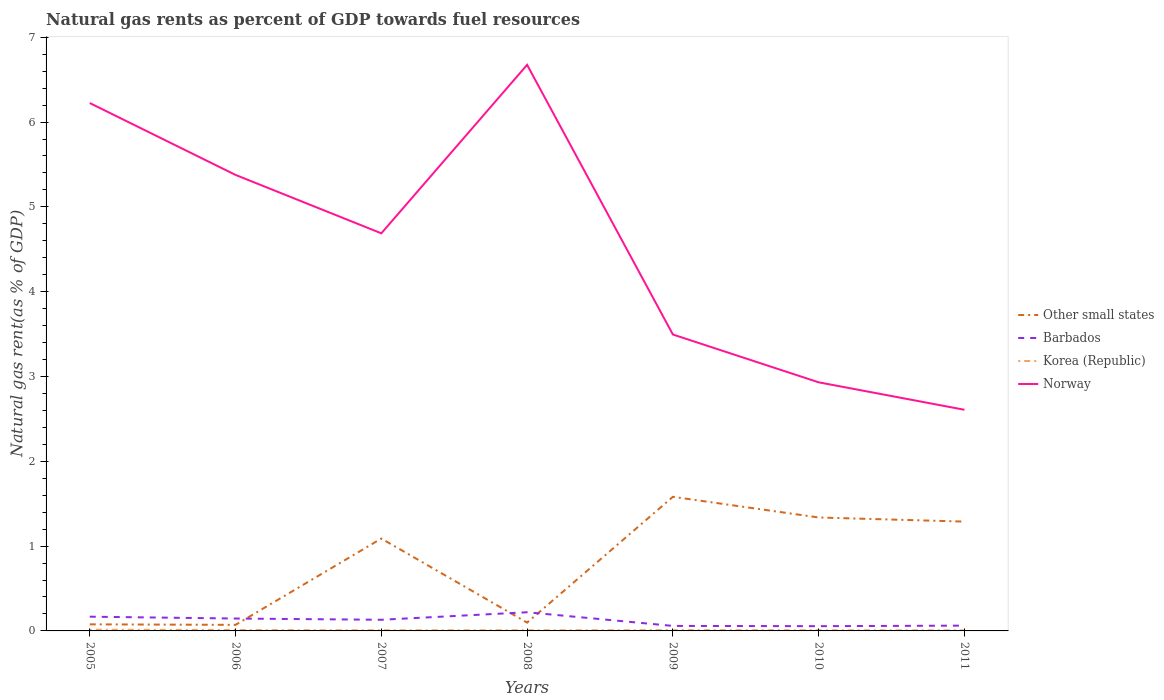Does the line corresponding to Norway intersect with the line corresponding to Korea (Republic)?
Keep it short and to the point. No. Is the number of lines equal to the number of legend labels?
Provide a short and direct response. Yes. Across all years, what is the maximum natural gas rent in Norway?
Ensure brevity in your answer.  2.61. What is the total natural gas rent in Norway in the graph?
Your response must be concise. 1.88. What is the difference between the highest and the second highest natural gas rent in Norway?
Give a very brief answer. 4.07. How many lines are there?
Your answer should be very brief. 4. How many years are there in the graph?
Give a very brief answer. 7. Does the graph contain any zero values?
Ensure brevity in your answer.  No. How many legend labels are there?
Offer a very short reply. 4. How are the legend labels stacked?
Offer a terse response. Vertical. What is the title of the graph?
Offer a very short reply. Natural gas rents as percent of GDP towards fuel resources. What is the label or title of the X-axis?
Provide a succinct answer. Years. What is the label or title of the Y-axis?
Your answer should be compact. Natural gas rent(as % of GDP). What is the Natural gas rent(as % of GDP) of Other small states in 2005?
Your response must be concise. 0.08. What is the Natural gas rent(as % of GDP) in Barbados in 2005?
Ensure brevity in your answer.  0.17. What is the Natural gas rent(as % of GDP) in Korea (Republic) in 2005?
Make the answer very short. 0.01. What is the Natural gas rent(as % of GDP) in Norway in 2005?
Ensure brevity in your answer.  6.22. What is the Natural gas rent(as % of GDP) of Other small states in 2006?
Provide a succinct answer. 0.07. What is the Natural gas rent(as % of GDP) in Barbados in 2006?
Your answer should be very brief. 0.15. What is the Natural gas rent(as % of GDP) in Korea (Republic) in 2006?
Ensure brevity in your answer.  0.01. What is the Natural gas rent(as % of GDP) in Norway in 2006?
Make the answer very short. 5.38. What is the Natural gas rent(as % of GDP) in Other small states in 2007?
Offer a very short reply. 1.09. What is the Natural gas rent(as % of GDP) of Barbados in 2007?
Provide a succinct answer. 0.13. What is the Natural gas rent(as % of GDP) in Korea (Republic) in 2007?
Keep it short and to the point. 0.01. What is the Natural gas rent(as % of GDP) in Norway in 2007?
Your answer should be compact. 4.69. What is the Natural gas rent(as % of GDP) in Other small states in 2008?
Give a very brief answer. 0.1. What is the Natural gas rent(as % of GDP) of Barbados in 2008?
Your response must be concise. 0.22. What is the Natural gas rent(as % of GDP) of Korea (Republic) in 2008?
Make the answer very short. 0.01. What is the Natural gas rent(as % of GDP) in Norway in 2008?
Offer a terse response. 6.67. What is the Natural gas rent(as % of GDP) in Other small states in 2009?
Offer a terse response. 1.58. What is the Natural gas rent(as % of GDP) of Barbados in 2009?
Provide a succinct answer. 0.06. What is the Natural gas rent(as % of GDP) in Korea (Republic) in 2009?
Ensure brevity in your answer.  0.01. What is the Natural gas rent(as % of GDP) in Norway in 2009?
Give a very brief answer. 3.49. What is the Natural gas rent(as % of GDP) of Other small states in 2010?
Your answer should be compact. 1.34. What is the Natural gas rent(as % of GDP) of Barbados in 2010?
Your answer should be very brief. 0.06. What is the Natural gas rent(as % of GDP) in Korea (Republic) in 2010?
Keep it short and to the point. 0.01. What is the Natural gas rent(as % of GDP) of Norway in 2010?
Provide a short and direct response. 2.93. What is the Natural gas rent(as % of GDP) in Other small states in 2011?
Provide a short and direct response. 1.29. What is the Natural gas rent(as % of GDP) of Barbados in 2011?
Offer a terse response. 0.06. What is the Natural gas rent(as % of GDP) of Korea (Republic) in 2011?
Make the answer very short. 0.01. What is the Natural gas rent(as % of GDP) of Norway in 2011?
Give a very brief answer. 2.61. Across all years, what is the maximum Natural gas rent(as % of GDP) of Other small states?
Ensure brevity in your answer.  1.58. Across all years, what is the maximum Natural gas rent(as % of GDP) in Barbados?
Your response must be concise. 0.22. Across all years, what is the maximum Natural gas rent(as % of GDP) in Korea (Republic)?
Offer a very short reply. 0.01. Across all years, what is the maximum Natural gas rent(as % of GDP) in Norway?
Provide a short and direct response. 6.67. Across all years, what is the minimum Natural gas rent(as % of GDP) in Other small states?
Your response must be concise. 0.07. Across all years, what is the minimum Natural gas rent(as % of GDP) in Barbados?
Make the answer very short. 0.06. Across all years, what is the minimum Natural gas rent(as % of GDP) in Korea (Republic)?
Your answer should be very brief. 0.01. Across all years, what is the minimum Natural gas rent(as % of GDP) of Norway?
Give a very brief answer. 2.61. What is the total Natural gas rent(as % of GDP) of Other small states in the graph?
Give a very brief answer. 5.54. What is the total Natural gas rent(as % of GDP) in Barbados in the graph?
Give a very brief answer. 0.84. What is the total Natural gas rent(as % of GDP) of Korea (Republic) in the graph?
Keep it short and to the point. 0.07. What is the total Natural gas rent(as % of GDP) of Norway in the graph?
Keep it short and to the point. 32. What is the difference between the Natural gas rent(as % of GDP) of Other small states in 2005 and that in 2006?
Your answer should be compact. 0.01. What is the difference between the Natural gas rent(as % of GDP) in Barbados in 2005 and that in 2006?
Give a very brief answer. 0.02. What is the difference between the Natural gas rent(as % of GDP) of Korea (Republic) in 2005 and that in 2006?
Offer a very short reply. 0. What is the difference between the Natural gas rent(as % of GDP) in Norway in 2005 and that in 2006?
Offer a terse response. 0.85. What is the difference between the Natural gas rent(as % of GDP) of Other small states in 2005 and that in 2007?
Give a very brief answer. -1.01. What is the difference between the Natural gas rent(as % of GDP) in Barbados in 2005 and that in 2007?
Your response must be concise. 0.04. What is the difference between the Natural gas rent(as % of GDP) in Korea (Republic) in 2005 and that in 2007?
Provide a short and direct response. 0.01. What is the difference between the Natural gas rent(as % of GDP) of Norway in 2005 and that in 2007?
Keep it short and to the point. 1.54. What is the difference between the Natural gas rent(as % of GDP) of Other small states in 2005 and that in 2008?
Provide a succinct answer. -0.02. What is the difference between the Natural gas rent(as % of GDP) in Barbados in 2005 and that in 2008?
Keep it short and to the point. -0.05. What is the difference between the Natural gas rent(as % of GDP) in Korea (Republic) in 2005 and that in 2008?
Offer a very short reply. 0.01. What is the difference between the Natural gas rent(as % of GDP) of Norway in 2005 and that in 2008?
Make the answer very short. -0.45. What is the difference between the Natural gas rent(as % of GDP) of Other small states in 2005 and that in 2009?
Your answer should be very brief. -1.5. What is the difference between the Natural gas rent(as % of GDP) of Barbados in 2005 and that in 2009?
Provide a succinct answer. 0.11. What is the difference between the Natural gas rent(as % of GDP) of Korea (Republic) in 2005 and that in 2009?
Ensure brevity in your answer.  0. What is the difference between the Natural gas rent(as % of GDP) in Norway in 2005 and that in 2009?
Give a very brief answer. 2.73. What is the difference between the Natural gas rent(as % of GDP) in Other small states in 2005 and that in 2010?
Offer a very short reply. -1.26. What is the difference between the Natural gas rent(as % of GDP) in Barbados in 2005 and that in 2010?
Your answer should be very brief. 0.11. What is the difference between the Natural gas rent(as % of GDP) of Korea (Republic) in 2005 and that in 2010?
Your answer should be compact. 0.01. What is the difference between the Natural gas rent(as % of GDP) of Norway in 2005 and that in 2010?
Make the answer very short. 3.29. What is the difference between the Natural gas rent(as % of GDP) of Other small states in 2005 and that in 2011?
Offer a very short reply. -1.21. What is the difference between the Natural gas rent(as % of GDP) in Barbados in 2005 and that in 2011?
Offer a very short reply. 0.11. What is the difference between the Natural gas rent(as % of GDP) in Korea (Republic) in 2005 and that in 2011?
Keep it short and to the point. 0.01. What is the difference between the Natural gas rent(as % of GDP) in Norway in 2005 and that in 2011?
Provide a succinct answer. 3.62. What is the difference between the Natural gas rent(as % of GDP) of Other small states in 2006 and that in 2007?
Ensure brevity in your answer.  -1.02. What is the difference between the Natural gas rent(as % of GDP) of Barbados in 2006 and that in 2007?
Your answer should be very brief. 0.01. What is the difference between the Natural gas rent(as % of GDP) of Korea (Republic) in 2006 and that in 2007?
Your answer should be compact. 0. What is the difference between the Natural gas rent(as % of GDP) in Norway in 2006 and that in 2007?
Offer a terse response. 0.69. What is the difference between the Natural gas rent(as % of GDP) in Other small states in 2006 and that in 2008?
Make the answer very short. -0.03. What is the difference between the Natural gas rent(as % of GDP) in Barbados in 2006 and that in 2008?
Give a very brief answer. -0.07. What is the difference between the Natural gas rent(as % of GDP) in Korea (Republic) in 2006 and that in 2008?
Make the answer very short. 0. What is the difference between the Natural gas rent(as % of GDP) in Norway in 2006 and that in 2008?
Keep it short and to the point. -1.3. What is the difference between the Natural gas rent(as % of GDP) of Other small states in 2006 and that in 2009?
Your response must be concise. -1.51. What is the difference between the Natural gas rent(as % of GDP) of Barbados in 2006 and that in 2009?
Ensure brevity in your answer.  0.09. What is the difference between the Natural gas rent(as % of GDP) in Korea (Republic) in 2006 and that in 2009?
Your response must be concise. 0. What is the difference between the Natural gas rent(as % of GDP) in Norway in 2006 and that in 2009?
Ensure brevity in your answer.  1.88. What is the difference between the Natural gas rent(as % of GDP) of Other small states in 2006 and that in 2010?
Your answer should be very brief. -1.27. What is the difference between the Natural gas rent(as % of GDP) in Barbados in 2006 and that in 2010?
Provide a short and direct response. 0.09. What is the difference between the Natural gas rent(as % of GDP) of Korea (Republic) in 2006 and that in 2010?
Your answer should be compact. 0. What is the difference between the Natural gas rent(as % of GDP) in Norway in 2006 and that in 2010?
Make the answer very short. 2.45. What is the difference between the Natural gas rent(as % of GDP) of Other small states in 2006 and that in 2011?
Your response must be concise. -1.22. What is the difference between the Natural gas rent(as % of GDP) in Barbados in 2006 and that in 2011?
Give a very brief answer. 0.08. What is the difference between the Natural gas rent(as % of GDP) in Korea (Republic) in 2006 and that in 2011?
Give a very brief answer. 0. What is the difference between the Natural gas rent(as % of GDP) of Norway in 2006 and that in 2011?
Make the answer very short. 2.77. What is the difference between the Natural gas rent(as % of GDP) of Barbados in 2007 and that in 2008?
Your answer should be compact. -0.09. What is the difference between the Natural gas rent(as % of GDP) in Korea (Republic) in 2007 and that in 2008?
Your answer should be very brief. -0. What is the difference between the Natural gas rent(as % of GDP) in Norway in 2007 and that in 2008?
Ensure brevity in your answer.  -1.99. What is the difference between the Natural gas rent(as % of GDP) in Other small states in 2007 and that in 2009?
Your response must be concise. -0.49. What is the difference between the Natural gas rent(as % of GDP) of Barbados in 2007 and that in 2009?
Provide a short and direct response. 0.07. What is the difference between the Natural gas rent(as % of GDP) of Korea (Republic) in 2007 and that in 2009?
Your response must be concise. -0. What is the difference between the Natural gas rent(as % of GDP) of Norway in 2007 and that in 2009?
Offer a terse response. 1.19. What is the difference between the Natural gas rent(as % of GDP) in Other small states in 2007 and that in 2010?
Give a very brief answer. -0.25. What is the difference between the Natural gas rent(as % of GDP) in Barbados in 2007 and that in 2010?
Your response must be concise. 0.08. What is the difference between the Natural gas rent(as % of GDP) of Korea (Republic) in 2007 and that in 2010?
Make the answer very short. -0. What is the difference between the Natural gas rent(as % of GDP) in Norway in 2007 and that in 2010?
Offer a very short reply. 1.76. What is the difference between the Natural gas rent(as % of GDP) of Other small states in 2007 and that in 2011?
Offer a terse response. -0.2. What is the difference between the Natural gas rent(as % of GDP) of Barbados in 2007 and that in 2011?
Provide a short and direct response. 0.07. What is the difference between the Natural gas rent(as % of GDP) in Korea (Republic) in 2007 and that in 2011?
Offer a terse response. 0. What is the difference between the Natural gas rent(as % of GDP) of Norway in 2007 and that in 2011?
Ensure brevity in your answer.  2.08. What is the difference between the Natural gas rent(as % of GDP) of Other small states in 2008 and that in 2009?
Provide a succinct answer. -1.48. What is the difference between the Natural gas rent(as % of GDP) in Barbados in 2008 and that in 2009?
Provide a succinct answer. 0.16. What is the difference between the Natural gas rent(as % of GDP) of Korea (Republic) in 2008 and that in 2009?
Ensure brevity in your answer.  -0. What is the difference between the Natural gas rent(as % of GDP) of Norway in 2008 and that in 2009?
Your response must be concise. 3.18. What is the difference between the Natural gas rent(as % of GDP) in Other small states in 2008 and that in 2010?
Make the answer very short. -1.24. What is the difference between the Natural gas rent(as % of GDP) in Barbados in 2008 and that in 2010?
Ensure brevity in your answer.  0.16. What is the difference between the Natural gas rent(as % of GDP) in Norway in 2008 and that in 2010?
Provide a succinct answer. 3.74. What is the difference between the Natural gas rent(as % of GDP) of Other small states in 2008 and that in 2011?
Your response must be concise. -1.19. What is the difference between the Natural gas rent(as % of GDP) of Barbados in 2008 and that in 2011?
Offer a terse response. 0.16. What is the difference between the Natural gas rent(as % of GDP) of Korea (Republic) in 2008 and that in 2011?
Make the answer very short. 0. What is the difference between the Natural gas rent(as % of GDP) of Norway in 2008 and that in 2011?
Give a very brief answer. 4.07. What is the difference between the Natural gas rent(as % of GDP) of Other small states in 2009 and that in 2010?
Provide a short and direct response. 0.24. What is the difference between the Natural gas rent(as % of GDP) of Barbados in 2009 and that in 2010?
Your response must be concise. 0. What is the difference between the Natural gas rent(as % of GDP) of Korea (Republic) in 2009 and that in 2010?
Your answer should be compact. 0. What is the difference between the Natural gas rent(as % of GDP) of Norway in 2009 and that in 2010?
Provide a succinct answer. 0.56. What is the difference between the Natural gas rent(as % of GDP) in Other small states in 2009 and that in 2011?
Provide a short and direct response. 0.29. What is the difference between the Natural gas rent(as % of GDP) of Barbados in 2009 and that in 2011?
Your response must be concise. -0. What is the difference between the Natural gas rent(as % of GDP) in Korea (Republic) in 2009 and that in 2011?
Offer a terse response. 0. What is the difference between the Natural gas rent(as % of GDP) of Norway in 2009 and that in 2011?
Ensure brevity in your answer.  0.89. What is the difference between the Natural gas rent(as % of GDP) in Other small states in 2010 and that in 2011?
Offer a very short reply. 0.05. What is the difference between the Natural gas rent(as % of GDP) of Barbados in 2010 and that in 2011?
Your answer should be compact. -0.01. What is the difference between the Natural gas rent(as % of GDP) of Korea (Republic) in 2010 and that in 2011?
Keep it short and to the point. 0. What is the difference between the Natural gas rent(as % of GDP) in Norway in 2010 and that in 2011?
Give a very brief answer. 0.32. What is the difference between the Natural gas rent(as % of GDP) of Other small states in 2005 and the Natural gas rent(as % of GDP) of Barbados in 2006?
Offer a very short reply. -0.07. What is the difference between the Natural gas rent(as % of GDP) in Other small states in 2005 and the Natural gas rent(as % of GDP) in Korea (Republic) in 2006?
Provide a short and direct response. 0.07. What is the difference between the Natural gas rent(as % of GDP) in Other small states in 2005 and the Natural gas rent(as % of GDP) in Norway in 2006?
Make the answer very short. -5.3. What is the difference between the Natural gas rent(as % of GDP) in Barbados in 2005 and the Natural gas rent(as % of GDP) in Korea (Republic) in 2006?
Give a very brief answer. 0.16. What is the difference between the Natural gas rent(as % of GDP) of Barbados in 2005 and the Natural gas rent(as % of GDP) of Norway in 2006?
Give a very brief answer. -5.21. What is the difference between the Natural gas rent(as % of GDP) in Korea (Republic) in 2005 and the Natural gas rent(as % of GDP) in Norway in 2006?
Keep it short and to the point. -5.36. What is the difference between the Natural gas rent(as % of GDP) in Other small states in 2005 and the Natural gas rent(as % of GDP) in Barbados in 2007?
Offer a very short reply. -0.05. What is the difference between the Natural gas rent(as % of GDP) in Other small states in 2005 and the Natural gas rent(as % of GDP) in Korea (Republic) in 2007?
Ensure brevity in your answer.  0.07. What is the difference between the Natural gas rent(as % of GDP) of Other small states in 2005 and the Natural gas rent(as % of GDP) of Norway in 2007?
Make the answer very short. -4.61. What is the difference between the Natural gas rent(as % of GDP) in Barbados in 2005 and the Natural gas rent(as % of GDP) in Korea (Republic) in 2007?
Keep it short and to the point. 0.16. What is the difference between the Natural gas rent(as % of GDP) of Barbados in 2005 and the Natural gas rent(as % of GDP) of Norway in 2007?
Keep it short and to the point. -4.52. What is the difference between the Natural gas rent(as % of GDP) of Korea (Republic) in 2005 and the Natural gas rent(as % of GDP) of Norway in 2007?
Provide a short and direct response. -4.67. What is the difference between the Natural gas rent(as % of GDP) in Other small states in 2005 and the Natural gas rent(as % of GDP) in Barbados in 2008?
Keep it short and to the point. -0.14. What is the difference between the Natural gas rent(as % of GDP) in Other small states in 2005 and the Natural gas rent(as % of GDP) in Korea (Republic) in 2008?
Offer a very short reply. 0.07. What is the difference between the Natural gas rent(as % of GDP) of Other small states in 2005 and the Natural gas rent(as % of GDP) of Norway in 2008?
Make the answer very short. -6.6. What is the difference between the Natural gas rent(as % of GDP) in Barbados in 2005 and the Natural gas rent(as % of GDP) in Korea (Republic) in 2008?
Give a very brief answer. 0.16. What is the difference between the Natural gas rent(as % of GDP) of Barbados in 2005 and the Natural gas rent(as % of GDP) of Norway in 2008?
Offer a very short reply. -6.51. What is the difference between the Natural gas rent(as % of GDP) of Korea (Republic) in 2005 and the Natural gas rent(as % of GDP) of Norway in 2008?
Provide a succinct answer. -6.66. What is the difference between the Natural gas rent(as % of GDP) in Other small states in 2005 and the Natural gas rent(as % of GDP) in Barbados in 2009?
Offer a terse response. 0.02. What is the difference between the Natural gas rent(as % of GDP) of Other small states in 2005 and the Natural gas rent(as % of GDP) of Korea (Republic) in 2009?
Provide a succinct answer. 0.07. What is the difference between the Natural gas rent(as % of GDP) of Other small states in 2005 and the Natural gas rent(as % of GDP) of Norway in 2009?
Your answer should be very brief. -3.42. What is the difference between the Natural gas rent(as % of GDP) in Barbados in 2005 and the Natural gas rent(as % of GDP) in Korea (Republic) in 2009?
Keep it short and to the point. 0.16. What is the difference between the Natural gas rent(as % of GDP) in Barbados in 2005 and the Natural gas rent(as % of GDP) in Norway in 2009?
Make the answer very short. -3.33. What is the difference between the Natural gas rent(as % of GDP) in Korea (Republic) in 2005 and the Natural gas rent(as % of GDP) in Norway in 2009?
Give a very brief answer. -3.48. What is the difference between the Natural gas rent(as % of GDP) in Other small states in 2005 and the Natural gas rent(as % of GDP) in Barbados in 2010?
Provide a short and direct response. 0.02. What is the difference between the Natural gas rent(as % of GDP) of Other small states in 2005 and the Natural gas rent(as % of GDP) of Korea (Republic) in 2010?
Your answer should be very brief. 0.07. What is the difference between the Natural gas rent(as % of GDP) of Other small states in 2005 and the Natural gas rent(as % of GDP) of Norway in 2010?
Your answer should be very brief. -2.85. What is the difference between the Natural gas rent(as % of GDP) of Barbados in 2005 and the Natural gas rent(as % of GDP) of Korea (Republic) in 2010?
Offer a very short reply. 0.16. What is the difference between the Natural gas rent(as % of GDP) of Barbados in 2005 and the Natural gas rent(as % of GDP) of Norway in 2010?
Provide a short and direct response. -2.76. What is the difference between the Natural gas rent(as % of GDP) of Korea (Republic) in 2005 and the Natural gas rent(as % of GDP) of Norway in 2010?
Offer a very short reply. -2.92. What is the difference between the Natural gas rent(as % of GDP) of Other small states in 2005 and the Natural gas rent(as % of GDP) of Barbados in 2011?
Give a very brief answer. 0.02. What is the difference between the Natural gas rent(as % of GDP) of Other small states in 2005 and the Natural gas rent(as % of GDP) of Korea (Republic) in 2011?
Ensure brevity in your answer.  0.07. What is the difference between the Natural gas rent(as % of GDP) in Other small states in 2005 and the Natural gas rent(as % of GDP) in Norway in 2011?
Your response must be concise. -2.53. What is the difference between the Natural gas rent(as % of GDP) of Barbados in 2005 and the Natural gas rent(as % of GDP) of Korea (Republic) in 2011?
Provide a short and direct response. 0.16. What is the difference between the Natural gas rent(as % of GDP) of Barbados in 2005 and the Natural gas rent(as % of GDP) of Norway in 2011?
Offer a very short reply. -2.44. What is the difference between the Natural gas rent(as % of GDP) in Korea (Republic) in 2005 and the Natural gas rent(as % of GDP) in Norway in 2011?
Give a very brief answer. -2.59. What is the difference between the Natural gas rent(as % of GDP) in Other small states in 2006 and the Natural gas rent(as % of GDP) in Barbados in 2007?
Provide a short and direct response. -0.06. What is the difference between the Natural gas rent(as % of GDP) in Other small states in 2006 and the Natural gas rent(as % of GDP) in Korea (Republic) in 2007?
Offer a very short reply. 0.06. What is the difference between the Natural gas rent(as % of GDP) of Other small states in 2006 and the Natural gas rent(as % of GDP) of Norway in 2007?
Your answer should be very brief. -4.62. What is the difference between the Natural gas rent(as % of GDP) in Barbados in 2006 and the Natural gas rent(as % of GDP) in Korea (Republic) in 2007?
Give a very brief answer. 0.14. What is the difference between the Natural gas rent(as % of GDP) in Barbados in 2006 and the Natural gas rent(as % of GDP) in Norway in 2007?
Your response must be concise. -4.54. What is the difference between the Natural gas rent(as % of GDP) in Korea (Republic) in 2006 and the Natural gas rent(as % of GDP) in Norway in 2007?
Provide a succinct answer. -4.68. What is the difference between the Natural gas rent(as % of GDP) of Other small states in 2006 and the Natural gas rent(as % of GDP) of Barbados in 2008?
Make the answer very short. -0.15. What is the difference between the Natural gas rent(as % of GDP) in Other small states in 2006 and the Natural gas rent(as % of GDP) in Korea (Republic) in 2008?
Keep it short and to the point. 0.06. What is the difference between the Natural gas rent(as % of GDP) in Other small states in 2006 and the Natural gas rent(as % of GDP) in Norway in 2008?
Keep it short and to the point. -6.6. What is the difference between the Natural gas rent(as % of GDP) in Barbados in 2006 and the Natural gas rent(as % of GDP) in Korea (Republic) in 2008?
Provide a short and direct response. 0.14. What is the difference between the Natural gas rent(as % of GDP) of Barbados in 2006 and the Natural gas rent(as % of GDP) of Norway in 2008?
Your answer should be very brief. -6.53. What is the difference between the Natural gas rent(as % of GDP) in Korea (Republic) in 2006 and the Natural gas rent(as % of GDP) in Norway in 2008?
Your answer should be very brief. -6.66. What is the difference between the Natural gas rent(as % of GDP) of Other small states in 2006 and the Natural gas rent(as % of GDP) of Barbados in 2009?
Give a very brief answer. 0.01. What is the difference between the Natural gas rent(as % of GDP) of Other small states in 2006 and the Natural gas rent(as % of GDP) of Korea (Republic) in 2009?
Keep it short and to the point. 0.06. What is the difference between the Natural gas rent(as % of GDP) in Other small states in 2006 and the Natural gas rent(as % of GDP) in Norway in 2009?
Your answer should be very brief. -3.42. What is the difference between the Natural gas rent(as % of GDP) of Barbados in 2006 and the Natural gas rent(as % of GDP) of Korea (Republic) in 2009?
Give a very brief answer. 0.14. What is the difference between the Natural gas rent(as % of GDP) of Barbados in 2006 and the Natural gas rent(as % of GDP) of Norway in 2009?
Keep it short and to the point. -3.35. What is the difference between the Natural gas rent(as % of GDP) of Korea (Republic) in 2006 and the Natural gas rent(as % of GDP) of Norway in 2009?
Provide a succinct answer. -3.48. What is the difference between the Natural gas rent(as % of GDP) in Other small states in 2006 and the Natural gas rent(as % of GDP) in Barbados in 2010?
Give a very brief answer. 0.02. What is the difference between the Natural gas rent(as % of GDP) of Other small states in 2006 and the Natural gas rent(as % of GDP) of Korea (Republic) in 2010?
Give a very brief answer. 0.06. What is the difference between the Natural gas rent(as % of GDP) of Other small states in 2006 and the Natural gas rent(as % of GDP) of Norway in 2010?
Your answer should be very brief. -2.86. What is the difference between the Natural gas rent(as % of GDP) in Barbados in 2006 and the Natural gas rent(as % of GDP) in Korea (Republic) in 2010?
Provide a succinct answer. 0.14. What is the difference between the Natural gas rent(as % of GDP) of Barbados in 2006 and the Natural gas rent(as % of GDP) of Norway in 2010?
Ensure brevity in your answer.  -2.79. What is the difference between the Natural gas rent(as % of GDP) of Korea (Republic) in 2006 and the Natural gas rent(as % of GDP) of Norway in 2010?
Keep it short and to the point. -2.92. What is the difference between the Natural gas rent(as % of GDP) in Other small states in 2006 and the Natural gas rent(as % of GDP) in Barbados in 2011?
Make the answer very short. 0.01. What is the difference between the Natural gas rent(as % of GDP) of Other small states in 2006 and the Natural gas rent(as % of GDP) of Korea (Republic) in 2011?
Offer a very short reply. 0.06. What is the difference between the Natural gas rent(as % of GDP) of Other small states in 2006 and the Natural gas rent(as % of GDP) of Norway in 2011?
Offer a very short reply. -2.54. What is the difference between the Natural gas rent(as % of GDP) of Barbados in 2006 and the Natural gas rent(as % of GDP) of Korea (Republic) in 2011?
Your answer should be compact. 0.14. What is the difference between the Natural gas rent(as % of GDP) in Barbados in 2006 and the Natural gas rent(as % of GDP) in Norway in 2011?
Offer a terse response. -2.46. What is the difference between the Natural gas rent(as % of GDP) of Korea (Republic) in 2006 and the Natural gas rent(as % of GDP) of Norway in 2011?
Provide a succinct answer. -2.6. What is the difference between the Natural gas rent(as % of GDP) in Other small states in 2007 and the Natural gas rent(as % of GDP) in Barbados in 2008?
Provide a short and direct response. 0.87. What is the difference between the Natural gas rent(as % of GDP) in Other small states in 2007 and the Natural gas rent(as % of GDP) in Korea (Republic) in 2008?
Give a very brief answer. 1.08. What is the difference between the Natural gas rent(as % of GDP) in Other small states in 2007 and the Natural gas rent(as % of GDP) in Norway in 2008?
Give a very brief answer. -5.59. What is the difference between the Natural gas rent(as % of GDP) in Barbados in 2007 and the Natural gas rent(as % of GDP) in Korea (Republic) in 2008?
Make the answer very short. 0.12. What is the difference between the Natural gas rent(as % of GDP) of Barbados in 2007 and the Natural gas rent(as % of GDP) of Norway in 2008?
Provide a short and direct response. -6.54. What is the difference between the Natural gas rent(as % of GDP) of Korea (Republic) in 2007 and the Natural gas rent(as % of GDP) of Norway in 2008?
Make the answer very short. -6.67. What is the difference between the Natural gas rent(as % of GDP) of Other small states in 2007 and the Natural gas rent(as % of GDP) of Barbados in 2009?
Your answer should be compact. 1.03. What is the difference between the Natural gas rent(as % of GDP) of Other small states in 2007 and the Natural gas rent(as % of GDP) of Korea (Republic) in 2009?
Provide a succinct answer. 1.08. What is the difference between the Natural gas rent(as % of GDP) in Other small states in 2007 and the Natural gas rent(as % of GDP) in Norway in 2009?
Ensure brevity in your answer.  -2.41. What is the difference between the Natural gas rent(as % of GDP) of Barbados in 2007 and the Natural gas rent(as % of GDP) of Korea (Republic) in 2009?
Provide a short and direct response. 0.12. What is the difference between the Natural gas rent(as % of GDP) in Barbados in 2007 and the Natural gas rent(as % of GDP) in Norway in 2009?
Ensure brevity in your answer.  -3.36. What is the difference between the Natural gas rent(as % of GDP) in Korea (Republic) in 2007 and the Natural gas rent(as % of GDP) in Norway in 2009?
Ensure brevity in your answer.  -3.49. What is the difference between the Natural gas rent(as % of GDP) of Other small states in 2007 and the Natural gas rent(as % of GDP) of Barbados in 2010?
Offer a very short reply. 1.03. What is the difference between the Natural gas rent(as % of GDP) of Other small states in 2007 and the Natural gas rent(as % of GDP) of Korea (Republic) in 2010?
Offer a very short reply. 1.08. What is the difference between the Natural gas rent(as % of GDP) in Other small states in 2007 and the Natural gas rent(as % of GDP) in Norway in 2010?
Give a very brief answer. -1.84. What is the difference between the Natural gas rent(as % of GDP) of Barbados in 2007 and the Natural gas rent(as % of GDP) of Korea (Republic) in 2010?
Provide a short and direct response. 0.12. What is the difference between the Natural gas rent(as % of GDP) of Barbados in 2007 and the Natural gas rent(as % of GDP) of Norway in 2010?
Offer a very short reply. -2.8. What is the difference between the Natural gas rent(as % of GDP) in Korea (Republic) in 2007 and the Natural gas rent(as % of GDP) in Norway in 2010?
Make the answer very short. -2.92. What is the difference between the Natural gas rent(as % of GDP) of Other small states in 2007 and the Natural gas rent(as % of GDP) of Barbados in 2011?
Your answer should be very brief. 1.03. What is the difference between the Natural gas rent(as % of GDP) in Other small states in 2007 and the Natural gas rent(as % of GDP) in Korea (Republic) in 2011?
Your answer should be very brief. 1.08. What is the difference between the Natural gas rent(as % of GDP) of Other small states in 2007 and the Natural gas rent(as % of GDP) of Norway in 2011?
Provide a succinct answer. -1.52. What is the difference between the Natural gas rent(as % of GDP) in Barbados in 2007 and the Natural gas rent(as % of GDP) in Korea (Republic) in 2011?
Keep it short and to the point. 0.12. What is the difference between the Natural gas rent(as % of GDP) in Barbados in 2007 and the Natural gas rent(as % of GDP) in Norway in 2011?
Your response must be concise. -2.48. What is the difference between the Natural gas rent(as % of GDP) of Korea (Republic) in 2007 and the Natural gas rent(as % of GDP) of Norway in 2011?
Make the answer very short. -2.6. What is the difference between the Natural gas rent(as % of GDP) in Other small states in 2008 and the Natural gas rent(as % of GDP) in Barbados in 2009?
Provide a short and direct response. 0.04. What is the difference between the Natural gas rent(as % of GDP) in Other small states in 2008 and the Natural gas rent(as % of GDP) in Korea (Republic) in 2009?
Make the answer very short. 0.09. What is the difference between the Natural gas rent(as % of GDP) in Other small states in 2008 and the Natural gas rent(as % of GDP) in Norway in 2009?
Your answer should be very brief. -3.4. What is the difference between the Natural gas rent(as % of GDP) in Barbados in 2008 and the Natural gas rent(as % of GDP) in Korea (Republic) in 2009?
Your answer should be very brief. 0.21. What is the difference between the Natural gas rent(as % of GDP) in Barbados in 2008 and the Natural gas rent(as % of GDP) in Norway in 2009?
Your response must be concise. -3.27. What is the difference between the Natural gas rent(as % of GDP) of Korea (Republic) in 2008 and the Natural gas rent(as % of GDP) of Norway in 2009?
Your answer should be compact. -3.49. What is the difference between the Natural gas rent(as % of GDP) of Other small states in 2008 and the Natural gas rent(as % of GDP) of Barbados in 2010?
Provide a succinct answer. 0.04. What is the difference between the Natural gas rent(as % of GDP) of Other small states in 2008 and the Natural gas rent(as % of GDP) of Korea (Republic) in 2010?
Your answer should be very brief. 0.09. What is the difference between the Natural gas rent(as % of GDP) of Other small states in 2008 and the Natural gas rent(as % of GDP) of Norway in 2010?
Provide a short and direct response. -2.83. What is the difference between the Natural gas rent(as % of GDP) of Barbados in 2008 and the Natural gas rent(as % of GDP) of Korea (Republic) in 2010?
Your answer should be very brief. 0.21. What is the difference between the Natural gas rent(as % of GDP) of Barbados in 2008 and the Natural gas rent(as % of GDP) of Norway in 2010?
Make the answer very short. -2.71. What is the difference between the Natural gas rent(as % of GDP) of Korea (Republic) in 2008 and the Natural gas rent(as % of GDP) of Norway in 2010?
Give a very brief answer. -2.92. What is the difference between the Natural gas rent(as % of GDP) of Other small states in 2008 and the Natural gas rent(as % of GDP) of Barbados in 2011?
Keep it short and to the point. 0.04. What is the difference between the Natural gas rent(as % of GDP) of Other small states in 2008 and the Natural gas rent(as % of GDP) of Korea (Republic) in 2011?
Your answer should be compact. 0.09. What is the difference between the Natural gas rent(as % of GDP) in Other small states in 2008 and the Natural gas rent(as % of GDP) in Norway in 2011?
Keep it short and to the point. -2.51. What is the difference between the Natural gas rent(as % of GDP) of Barbados in 2008 and the Natural gas rent(as % of GDP) of Korea (Republic) in 2011?
Your answer should be very brief. 0.21. What is the difference between the Natural gas rent(as % of GDP) in Barbados in 2008 and the Natural gas rent(as % of GDP) in Norway in 2011?
Provide a short and direct response. -2.39. What is the difference between the Natural gas rent(as % of GDP) in Korea (Republic) in 2008 and the Natural gas rent(as % of GDP) in Norway in 2011?
Your answer should be compact. -2.6. What is the difference between the Natural gas rent(as % of GDP) in Other small states in 2009 and the Natural gas rent(as % of GDP) in Barbados in 2010?
Provide a short and direct response. 1.53. What is the difference between the Natural gas rent(as % of GDP) in Other small states in 2009 and the Natural gas rent(as % of GDP) in Korea (Republic) in 2010?
Offer a terse response. 1.57. What is the difference between the Natural gas rent(as % of GDP) in Other small states in 2009 and the Natural gas rent(as % of GDP) in Norway in 2010?
Offer a terse response. -1.35. What is the difference between the Natural gas rent(as % of GDP) of Barbados in 2009 and the Natural gas rent(as % of GDP) of Korea (Republic) in 2010?
Provide a short and direct response. 0.05. What is the difference between the Natural gas rent(as % of GDP) in Barbados in 2009 and the Natural gas rent(as % of GDP) in Norway in 2010?
Your answer should be very brief. -2.87. What is the difference between the Natural gas rent(as % of GDP) of Korea (Republic) in 2009 and the Natural gas rent(as % of GDP) of Norway in 2010?
Give a very brief answer. -2.92. What is the difference between the Natural gas rent(as % of GDP) in Other small states in 2009 and the Natural gas rent(as % of GDP) in Barbados in 2011?
Ensure brevity in your answer.  1.52. What is the difference between the Natural gas rent(as % of GDP) in Other small states in 2009 and the Natural gas rent(as % of GDP) in Korea (Republic) in 2011?
Your answer should be very brief. 1.57. What is the difference between the Natural gas rent(as % of GDP) in Other small states in 2009 and the Natural gas rent(as % of GDP) in Norway in 2011?
Provide a short and direct response. -1.03. What is the difference between the Natural gas rent(as % of GDP) in Barbados in 2009 and the Natural gas rent(as % of GDP) in Korea (Republic) in 2011?
Your answer should be very brief. 0.05. What is the difference between the Natural gas rent(as % of GDP) in Barbados in 2009 and the Natural gas rent(as % of GDP) in Norway in 2011?
Your answer should be very brief. -2.55. What is the difference between the Natural gas rent(as % of GDP) of Korea (Republic) in 2009 and the Natural gas rent(as % of GDP) of Norway in 2011?
Your response must be concise. -2.6. What is the difference between the Natural gas rent(as % of GDP) of Other small states in 2010 and the Natural gas rent(as % of GDP) of Barbados in 2011?
Your response must be concise. 1.28. What is the difference between the Natural gas rent(as % of GDP) in Other small states in 2010 and the Natural gas rent(as % of GDP) in Korea (Republic) in 2011?
Offer a terse response. 1.33. What is the difference between the Natural gas rent(as % of GDP) in Other small states in 2010 and the Natural gas rent(as % of GDP) in Norway in 2011?
Provide a short and direct response. -1.27. What is the difference between the Natural gas rent(as % of GDP) in Barbados in 2010 and the Natural gas rent(as % of GDP) in Korea (Republic) in 2011?
Ensure brevity in your answer.  0.05. What is the difference between the Natural gas rent(as % of GDP) of Barbados in 2010 and the Natural gas rent(as % of GDP) of Norway in 2011?
Give a very brief answer. -2.55. What is the difference between the Natural gas rent(as % of GDP) of Korea (Republic) in 2010 and the Natural gas rent(as % of GDP) of Norway in 2011?
Your response must be concise. -2.6. What is the average Natural gas rent(as % of GDP) of Other small states per year?
Give a very brief answer. 0.79. What is the average Natural gas rent(as % of GDP) of Barbados per year?
Your answer should be very brief. 0.12. What is the average Natural gas rent(as % of GDP) in Korea (Republic) per year?
Provide a succinct answer. 0.01. What is the average Natural gas rent(as % of GDP) in Norway per year?
Your answer should be very brief. 4.57. In the year 2005, what is the difference between the Natural gas rent(as % of GDP) of Other small states and Natural gas rent(as % of GDP) of Barbados?
Provide a succinct answer. -0.09. In the year 2005, what is the difference between the Natural gas rent(as % of GDP) in Other small states and Natural gas rent(as % of GDP) in Korea (Republic)?
Provide a short and direct response. 0.06. In the year 2005, what is the difference between the Natural gas rent(as % of GDP) of Other small states and Natural gas rent(as % of GDP) of Norway?
Your response must be concise. -6.15. In the year 2005, what is the difference between the Natural gas rent(as % of GDP) of Barbados and Natural gas rent(as % of GDP) of Korea (Republic)?
Offer a very short reply. 0.15. In the year 2005, what is the difference between the Natural gas rent(as % of GDP) of Barbados and Natural gas rent(as % of GDP) of Norway?
Provide a short and direct response. -6.06. In the year 2005, what is the difference between the Natural gas rent(as % of GDP) of Korea (Republic) and Natural gas rent(as % of GDP) of Norway?
Give a very brief answer. -6.21. In the year 2006, what is the difference between the Natural gas rent(as % of GDP) in Other small states and Natural gas rent(as % of GDP) in Barbados?
Offer a very short reply. -0.07. In the year 2006, what is the difference between the Natural gas rent(as % of GDP) of Other small states and Natural gas rent(as % of GDP) of Korea (Republic)?
Keep it short and to the point. 0.06. In the year 2006, what is the difference between the Natural gas rent(as % of GDP) of Other small states and Natural gas rent(as % of GDP) of Norway?
Your answer should be compact. -5.31. In the year 2006, what is the difference between the Natural gas rent(as % of GDP) in Barbados and Natural gas rent(as % of GDP) in Korea (Republic)?
Your response must be concise. 0.14. In the year 2006, what is the difference between the Natural gas rent(as % of GDP) of Barbados and Natural gas rent(as % of GDP) of Norway?
Offer a very short reply. -5.23. In the year 2006, what is the difference between the Natural gas rent(as % of GDP) in Korea (Republic) and Natural gas rent(as % of GDP) in Norway?
Offer a very short reply. -5.37. In the year 2007, what is the difference between the Natural gas rent(as % of GDP) in Other small states and Natural gas rent(as % of GDP) in Barbados?
Your answer should be very brief. 0.96. In the year 2007, what is the difference between the Natural gas rent(as % of GDP) in Other small states and Natural gas rent(as % of GDP) in Korea (Republic)?
Keep it short and to the point. 1.08. In the year 2007, what is the difference between the Natural gas rent(as % of GDP) in Other small states and Natural gas rent(as % of GDP) in Norway?
Give a very brief answer. -3.6. In the year 2007, what is the difference between the Natural gas rent(as % of GDP) of Barbados and Natural gas rent(as % of GDP) of Korea (Republic)?
Your response must be concise. 0.12. In the year 2007, what is the difference between the Natural gas rent(as % of GDP) in Barbados and Natural gas rent(as % of GDP) in Norway?
Provide a succinct answer. -4.56. In the year 2007, what is the difference between the Natural gas rent(as % of GDP) of Korea (Republic) and Natural gas rent(as % of GDP) of Norway?
Offer a terse response. -4.68. In the year 2008, what is the difference between the Natural gas rent(as % of GDP) in Other small states and Natural gas rent(as % of GDP) in Barbados?
Offer a very short reply. -0.12. In the year 2008, what is the difference between the Natural gas rent(as % of GDP) of Other small states and Natural gas rent(as % of GDP) of Korea (Republic)?
Your answer should be very brief. 0.09. In the year 2008, what is the difference between the Natural gas rent(as % of GDP) in Other small states and Natural gas rent(as % of GDP) in Norway?
Ensure brevity in your answer.  -6.58. In the year 2008, what is the difference between the Natural gas rent(as % of GDP) of Barbados and Natural gas rent(as % of GDP) of Korea (Republic)?
Your answer should be very brief. 0.21. In the year 2008, what is the difference between the Natural gas rent(as % of GDP) of Barbados and Natural gas rent(as % of GDP) of Norway?
Give a very brief answer. -6.45. In the year 2008, what is the difference between the Natural gas rent(as % of GDP) of Korea (Republic) and Natural gas rent(as % of GDP) of Norway?
Keep it short and to the point. -6.67. In the year 2009, what is the difference between the Natural gas rent(as % of GDP) in Other small states and Natural gas rent(as % of GDP) in Barbados?
Make the answer very short. 1.52. In the year 2009, what is the difference between the Natural gas rent(as % of GDP) of Other small states and Natural gas rent(as % of GDP) of Korea (Republic)?
Provide a short and direct response. 1.57. In the year 2009, what is the difference between the Natural gas rent(as % of GDP) of Other small states and Natural gas rent(as % of GDP) of Norway?
Provide a succinct answer. -1.91. In the year 2009, what is the difference between the Natural gas rent(as % of GDP) of Barbados and Natural gas rent(as % of GDP) of Korea (Republic)?
Provide a short and direct response. 0.05. In the year 2009, what is the difference between the Natural gas rent(as % of GDP) in Barbados and Natural gas rent(as % of GDP) in Norway?
Make the answer very short. -3.44. In the year 2009, what is the difference between the Natural gas rent(as % of GDP) in Korea (Republic) and Natural gas rent(as % of GDP) in Norway?
Provide a succinct answer. -3.49. In the year 2010, what is the difference between the Natural gas rent(as % of GDP) in Other small states and Natural gas rent(as % of GDP) in Barbados?
Offer a terse response. 1.28. In the year 2010, what is the difference between the Natural gas rent(as % of GDP) in Other small states and Natural gas rent(as % of GDP) in Korea (Republic)?
Give a very brief answer. 1.33. In the year 2010, what is the difference between the Natural gas rent(as % of GDP) in Other small states and Natural gas rent(as % of GDP) in Norway?
Ensure brevity in your answer.  -1.59. In the year 2010, what is the difference between the Natural gas rent(as % of GDP) of Barbados and Natural gas rent(as % of GDP) of Korea (Republic)?
Give a very brief answer. 0.05. In the year 2010, what is the difference between the Natural gas rent(as % of GDP) in Barbados and Natural gas rent(as % of GDP) in Norway?
Your response must be concise. -2.88. In the year 2010, what is the difference between the Natural gas rent(as % of GDP) in Korea (Republic) and Natural gas rent(as % of GDP) in Norway?
Your answer should be compact. -2.92. In the year 2011, what is the difference between the Natural gas rent(as % of GDP) of Other small states and Natural gas rent(as % of GDP) of Barbados?
Provide a succinct answer. 1.23. In the year 2011, what is the difference between the Natural gas rent(as % of GDP) of Other small states and Natural gas rent(as % of GDP) of Korea (Republic)?
Ensure brevity in your answer.  1.28. In the year 2011, what is the difference between the Natural gas rent(as % of GDP) in Other small states and Natural gas rent(as % of GDP) in Norway?
Keep it short and to the point. -1.32. In the year 2011, what is the difference between the Natural gas rent(as % of GDP) in Barbados and Natural gas rent(as % of GDP) in Korea (Republic)?
Make the answer very short. 0.06. In the year 2011, what is the difference between the Natural gas rent(as % of GDP) of Barbados and Natural gas rent(as % of GDP) of Norway?
Keep it short and to the point. -2.54. In the year 2011, what is the difference between the Natural gas rent(as % of GDP) of Korea (Republic) and Natural gas rent(as % of GDP) of Norway?
Your answer should be very brief. -2.6. What is the ratio of the Natural gas rent(as % of GDP) in Other small states in 2005 to that in 2006?
Your answer should be very brief. 1.08. What is the ratio of the Natural gas rent(as % of GDP) of Barbados in 2005 to that in 2006?
Provide a succinct answer. 1.15. What is the ratio of the Natural gas rent(as % of GDP) in Korea (Republic) in 2005 to that in 2006?
Provide a short and direct response. 1.3. What is the ratio of the Natural gas rent(as % of GDP) of Norway in 2005 to that in 2006?
Offer a terse response. 1.16. What is the ratio of the Natural gas rent(as % of GDP) of Other small states in 2005 to that in 2007?
Provide a succinct answer. 0.07. What is the ratio of the Natural gas rent(as % of GDP) in Barbados in 2005 to that in 2007?
Give a very brief answer. 1.28. What is the ratio of the Natural gas rent(as % of GDP) in Korea (Republic) in 2005 to that in 2007?
Give a very brief answer. 1.79. What is the ratio of the Natural gas rent(as % of GDP) in Norway in 2005 to that in 2007?
Ensure brevity in your answer.  1.33. What is the ratio of the Natural gas rent(as % of GDP) in Other small states in 2005 to that in 2008?
Give a very brief answer. 0.79. What is the ratio of the Natural gas rent(as % of GDP) of Barbados in 2005 to that in 2008?
Offer a very short reply. 0.76. What is the ratio of the Natural gas rent(as % of GDP) of Korea (Republic) in 2005 to that in 2008?
Your answer should be compact. 1.77. What is the ratio of the Natural gas rent(as % of GDP) in Norway in 2005 to that in 2008?
Your answer should be very brief. 0.93. What is the ratio of the Natural gas rent(as % of GDP) of Other small states in 2005 to that in 2009?
Your answer should be compact. 0.05. What is the ratio of the Natural gas rent(as % of GDP) in Barbados in 2005 to that in 2009?
Provide a short and direct response. 2.84. What is the ratio of the Natural gas rent(as % of GDP) in Korea (Republic) in 2005 to that in 2009?
Offer a terse response. 1.48. What is the ratio of the Natural gas rent(as % of GDP) of Norway in 2005 to that in 2009?
Ensure brevity in your answer.  1.78. What is the ratio of the Natural gas rent(as % of GDP) in Other small states in 2005 to that in 2010?
Make the answer very short. 0.06. What is the ratio of the Natural gas rent(as % of GDP) of Barbados in 2005 to that in 2010?
Offer a terse response. 2.99. What is the ratio of the Natural gas rent(as % of GDP) of Korea (Republic) in 2005 to that in 2010?
Ensure brevity in your answer.  1.76. What is the ratio of the Natural gas rent(as % of GDP) in Norway in 2005 to that in 2010?
Provide a succinct answer. 2.12. What is the ratio of the Natural gas rent(as % of GDP) of Other small states in 2005 to that in 2011?
Your response must be concise. 0.06. What is the ratio of the Natural gas rent(as % of GDP) of Barbados in 2005 to that in 2011?
Ensure brevity in your answer.  2.69. What is the ratio of the Natural gas rent(as % of GDP) of Korea (Republic) in 2005 to that in 2011?
Your answer should be compact. 2.09. What is the ratio of the Natural gas rent(as % of GDP) of Norway in 2005 to that in 2011?
Offer a very short reply. 2.39. What is the ratio of the Natural gas rent(as % of GDP) in Other small states in 2006 to that in 2007?
Ensure brevity in your answer.  0.07. What is the ratio of the Natural gas rent(as % of GDP) in Barbados in 2006 to that in 2007?
Your answer should be compact. 1.11. What is the ratio of the Natural gas rent(as % of GDP) of Korea (Republic) in 2006 to that in 2007?
Ensure brevity in your answer.  1.37. What is the ratio of the Natural gas rent(as % of GDP) in Norway in 2006 to that in 2007?
Make the answer very short. 1.15. What is the ratio of the Natural gas rent(as % of GDP) of Other small states in 2006 to that in 2008?
Your answer should be very brief. 0.73. What is the ratio of the Natural gas rent(as % of GDP) of Barbados in 2006 to that in 2008?
Ensure brevity in your answer.  0.66. What is the ratio of the Natural gas rent(as % of GDP) of Korea (Republic) in 2006 to that in 2008?
Provide a short and direct response. 1.36. What is the ratio of the Natural gas rent(as % of GDP) of Norway in 2006 to that in 2008?
Give a very brief answer. 0.81. What is the ratio of the Natural gas rent(as % of GDP) of Other small states in 2006 to that in 2009?
Your answer should be very brief. 0.05. What is the ratio of the Natural gas rent(as % of GDP) of Barbados in 2006 to that in 2009?
Your answer should be compact. 2.47. What is the ratio of the Natural gas rent(as % of GDP) of Korea (Republic) in 2006 to that in 2009?
Offer a very short reply. 1.14. What is the ratio of the Natural gas rent(as % of GDP) in Norway in 2006 to that in 2009?
Ensure brevity in your answer.  1.54. What is the ratio of the Natural gas rent(as % of GDP) of Other small states in 2006 to that in 2010?
Your response must be concise. 0.05. What is the ratio of the Natural gas rent(as % of GDP) of Barbados in 2006 to that in 2010?
Ensure brevity in your answer.  2.61. What is the ratio of the Natural gas rent(as % of GDP) of Korea (Republic) in 2006 to that in 2010?
Offer a terse response. 1.36. What is the ratio of the Natural gas rent(as % of GDP) in Norway in 2006 to that in 2010?
Provide a short and direct response. 1.83. What is the ratio of the Natural gas rent(as % of GDP) in Other small states in 2006 to that in 2011?
Give a very brief answer. 0.06. What is the ratio of the Natural gas rent(as % of GDP) of Barbados in 2006 to that in 2011?
Offer a very short reply. 2.34. What is the ratio of the Natural gas rent(as % of GDP) of Korea (Republic) in 2006 to that in 2011?
Offer a very short reply. 1.6. What is the ratio of the Natural gas rent(as % of GDP) in Norway in 2006 to that in 2011?
Give a very brief answer. 2.06. What is the ratio of the Natural gas rent(as % of GDP) in Other small states in 2007 to that in 2008?
Your response must be concise. 11.12. What is the ratio of the Natural gas rent(as % of GDP) in Barbados in 2007 to that in 2008?
Offer a very short reply. 0.6. What is the ratio of the Natural gas rent(as % of GDP) in Norway in 2007 to that in 2008?
Your response must be concise. 0.7. What is the ratio of the Natural gas rent(as % of GDP) in Other small states in 2007 to that in 2009?
Give a very brief answer. 0.69. What is the ratio of the Natural gas rent(as % of GDP) of Barbados in 2007 to that in 2009?
Provide a succinct answer. 2.23. What is the ratio of the Natural gas rent(as % of GDP) in Korea (Republic) in 2007 to that in 2009?
Your answer should be compact. 0.83. What is the ratio of the Natural gas rent(as % of GDP) of Norway in 2007 to that in 2009?
Ensure brevity in your answer.  1.34. What is the ratio of the Natural gas rent(as % of GDP) in Other small states in 2007 to that in 2010?
Your answer should be very brief. 0.81. What is the ratio of the Natural gas rent(as % of GDP) in Barbados in 2007 to that in 2010?
Offer a terse response. 2.35. What is the ratio of the Natural gas rent(as % of GDP) of Korea (Republic) in 2007 to that in 2010?
Offer a terse response. 0.99. What is the ratio of the Natural gas rent(as % of GDP) of Norway in 2007 to that in 2010?
Offer a terse response. 1.6. What is the ratio of the Natural gas rent(as % of GDP) of Other small states in 2007 to that in 2011?
Your response must be concise. 0.85. What is the ratio of the Natural gas rent(as % of GDP) of Barbados in 2007 to that in 2011?
Your answer should be very brief. 2.11. What is the ratio of the Natural gas rent(as % of GDP) of Korea (Republic) in 2007 to that in 2011?
Give a very brief answer. 1.17. What is the ratio of the Natural gas rent(as % of GDP) of Norway in 2007 to that in 2011?
Offer a very short reply. 1.8. What is the ratio of the Natural gas rent(as % of GDP) in Other small states in 2008 to that in 2009?
Ensure brevity in your answer.  0.06. What is the ratio of the Natural gas rent(as % of GDP) of Barbados in 2008 to that in 2009?
Keep it short and to the point. 3.73. What is the ratio of the Natural gas rent(as % of GDP) of Korea (Republic) in 2008 to that in 2009?
Your answer should be compact. 0.84. What is the ratio of the Natural gas rent(as % of GDP) of Norway in 2008 to that in 2009?
Give a very brief answer. 1.91. What is the ratio of the Natural gas rent(as % of GDP) of Other small states in 2008 to that in 2010?
Provide a short and direct response. 0.07. What is the ratio of the Natural gas rent(as % of GDP) of Barbados in 2008 to that in 2010?
Your answer should be compact. 3.93. What is the ratio of the Natural gas rent(as % of GDP) of Korea (Republic) in 2008 to that in 2010?
Offer a terse response. 0.99. What is the ratio of the Natural gas rent(as % of GDP) of Norway in 2008 to that in 2010?
Provide a succinct answer. 2.28. What is the ratio of the Natural gas rent(as % of GDP) in Other small states in 2008 to that in 2011?
Make the answer very short. 0.08. What is the ratio of the Natural gas rent(as % of GDP) of Barbados in 2008 to that in 2011?
Your answer should be compact. 3.53. What is the ratio of the Natural gas rent(as % of GDP) of Korea (Republic) in 2008 to that in 2011?
Your response must be concise. 1.18. What is the ratio of the Natural gas rent(as % of GDP) in Norway in 2008 to that in 2011?
Provide a succinct answer. 2.56. What is the ratio of the Natural gas rent(as % of GDP) of Other small states in 2009 to that in 2010?
Provide a succinct answer. 1.18. What is the ratio of the Natural gas rent(as % of GDP) of Barbados in 2009 to that in 2010?
Your answer should be compact. 1.05. What is the ratio of the Natural gas rent(as % of GDP) in Korea (Republic) in 2009 to that in 2010?
Ensure brevity in your answer.  1.19. What is the ratio of the Natural gas rent(as % of GDP) of Norway in 2009 to that in 2010?
Ensure brevity in your answer.  1.19. What is the ratio of the Natural gas rent(as % of GDP) in Other small states in 2009 to that in 2011?
Ensure brevity in your answer.  1.23. What is the ratio of the Natural gas rent(as % of GDP) of Barbados in 2009 to that in 2011?
Keep it short and to the point. 0.95. What is the ratio of the Natural gas rent(as % of GDP) of Korea (Republic) in 2009 to that in 2011?
Ensure brevity in your answer.  1.41. What is the ratio of the Natural gas rent(as % of GDP) of Norway in 2009 to that in 2011?
Your answer should be very brief. 1.34. What is the ratio of the Natural gas rent(as % of GDP) of Other small states in 2010 to that in 2011?
Your response must be concise. 1.04. What is the ratio of the Natural gas rent(as % of GDP) of Barbados in 2010 to that in 2011?
Offer a very short reply. 0.9. What is the ratio of the Natural gas rent(as % of GDP) in Korea (Republic) in 2010 to that in 2011?
Offer a very short reply. 1.18. What is the ratio of the Natural gas rent(as % of GDP) in Norway in 2010 to that in 2011?
Provide a short and direct response. 1.12. What is the difference between the highest and the second highest Natural gas rent(as % of GDP) in Other small states?
Provide a succinct answer. 0.24. What is the difference between the highest and the second highest Natural gas rent(as % of GDP) in Barbados?
Ensure brevity in your answer.  0.05. What is the difference between the highest and the second highest Natural gas rent(as % of GDP) of Korea (Republic)?
Ensure brevity in your answer.  0. What is the difference between the highest and the second highest Natural gas rent(as % of GDP) in Norway?
Offer a terse response. 0.45. What is the difference between the highest and the lowest Natural gas rent(as % of GDP) in Other small states?
Provide a short and direct response. 1.51. What is the difference between the highest and the lowest Natural gas rent(as % of GDP) of Barbados?
Provide a succinct answer. 0.16. What is the difference between the highest and the lowest Natural gas rent(as % of GDP) in Korea (Republic)?
Your response must be concise. 0.01. What is the difference between the highest and the lowest Natural gas rent(as % of GDP) in Norway?
Provide a short and direct response. 4.07. 